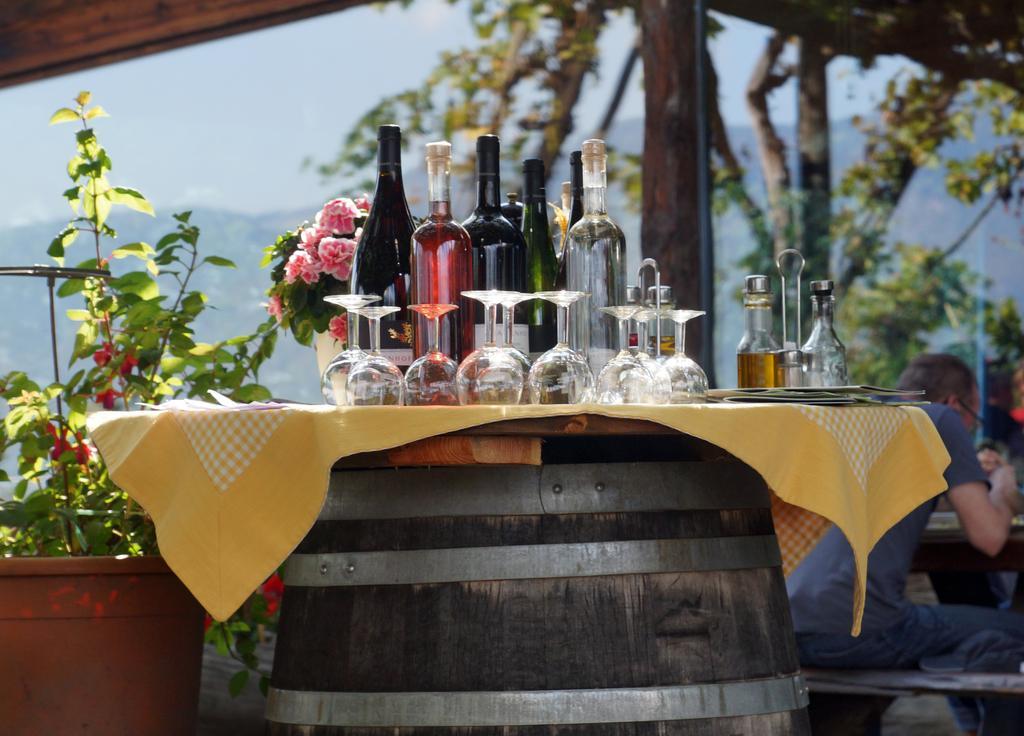Could you give a brief overview of what you see in this image? In this image I see a table on which there are glasses and bottles on it. In the background I see few plants, trees and a person over here who is sitting. 